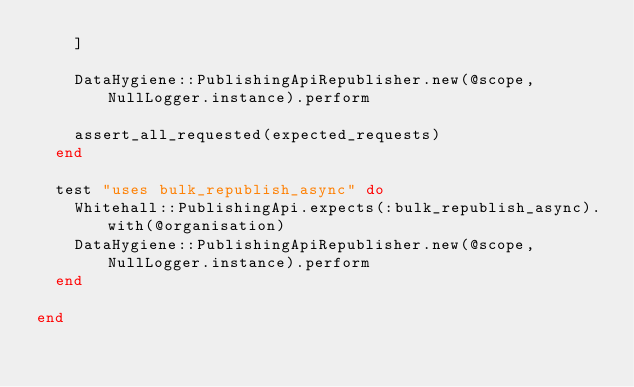<code> <loc_0><loc_0><loc_500><loc_500><_Ruby_>    ]

    DataHygiene::PublishingApiRepublisher.new(@scope, NullLogger.instance).perform

    assert_all_requested(expected_requests)
  end

  test "uses bulk_republish_async" do
    Whitehall::PublishingApi.expects(:bulk_republish_async).with(@organisation)
    DataHygiene::PublishingApiRepublisher.new(@scope, NullLogger.instance).perform
  end

end
</code> 